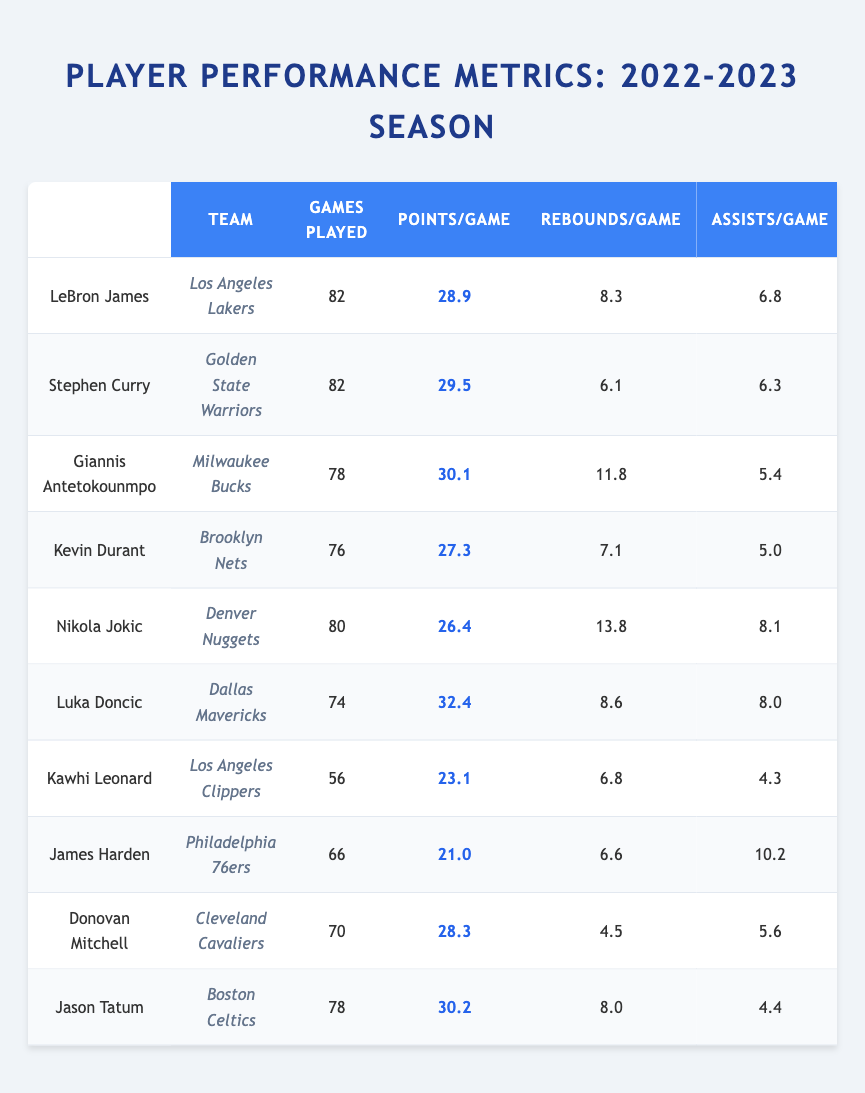What is the highest Points Per Game recorded in the table? By scanning the "Points/Game" column, the highest value is found to be 32.4, corresponding to Luka Doncic.
Answer: 32.4 How many games did Kawhi Leonard play during the season? Looking at the "Games Played" column for Kawhi Leonard, the value is 56.
Answer: 56 Which player had the highest Free Throw Percentage? The "FT%" column is checked to find the highest percentage, which is 92.3 from Stephen Curry.
Answer: 92.3% What is the average number of Assists Per Game for the listed players? First, sum the assists: 6.8 (LeBron) + 6.3 (Curry) + 5.4 (Giannis) + 5.0 (Durant) + 8.1 (Nikola) + 8.0 (Luka) + 4.3 (Kawhi) + 10.2 (James) + 5.6 (Mitchell) + 4.4 (Tatum) = 60.7. There are 10 players, hence average = 60.7/10 = 6.07.
Answer: 6.07 Did Kevin Durant have more Rebounds Per Game than James Harden? Compare the "Rebounds/Game" for each: Kevin Durant had 7.1, while James Harden had 6.6. So yes, Durant had more.
Answer: Yes How many players played more than 80 games? Checking the "Games Played" column: LeBron James (82) and Stephen Curry (82) both played more than 80 games. There are 2 players fitting this criterion.
Answer: 2 What is the difference in Points Per Game between Luka Doncic and Kawhi Leonard? Luka Doncic had 32.4 and Kawhi Leonard had 23.1. The difference is 32.4 - 23.1 = 9.3.
Answer: 9.3 Which player has both the highest Field Goal Percentage and the highest Rebounds Per Game? Reviewing the table, Nikola Jokic has the highest Field Goal Percentage at 58.3% and also the highest Rebounds at 13.8.
Answer: Nikola Jokic Which team does the player with the most Steals Per Game play for? The player with the most Steals Per Game is Kawhi Leonard with 1.6 steals, and he plays for the Los Angeles Clippers.
Answer: Los Angeles Clippers Who had the lowest Three Point Percentage among the listed players? Scanning the "3PT%" column reveals Kawhi Leonard with 36.5% as the lowest percentage.
Answer: 36.5% 